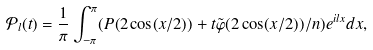Convert formula to latex. <formula><loc_0><loc_0><loc_500><loc_500>\mathcal { P } _ { l } ( t ) = \frac { 1 } { \pi } \int _ { - \pi } ^ { \pi } ( P ( 2 \cos ( x / 2 ) ) + t \tilde { \varphi } ( 2 \cos ( x / 2 ) ) / n ) e ^ { i l x } d x ,</formula> 